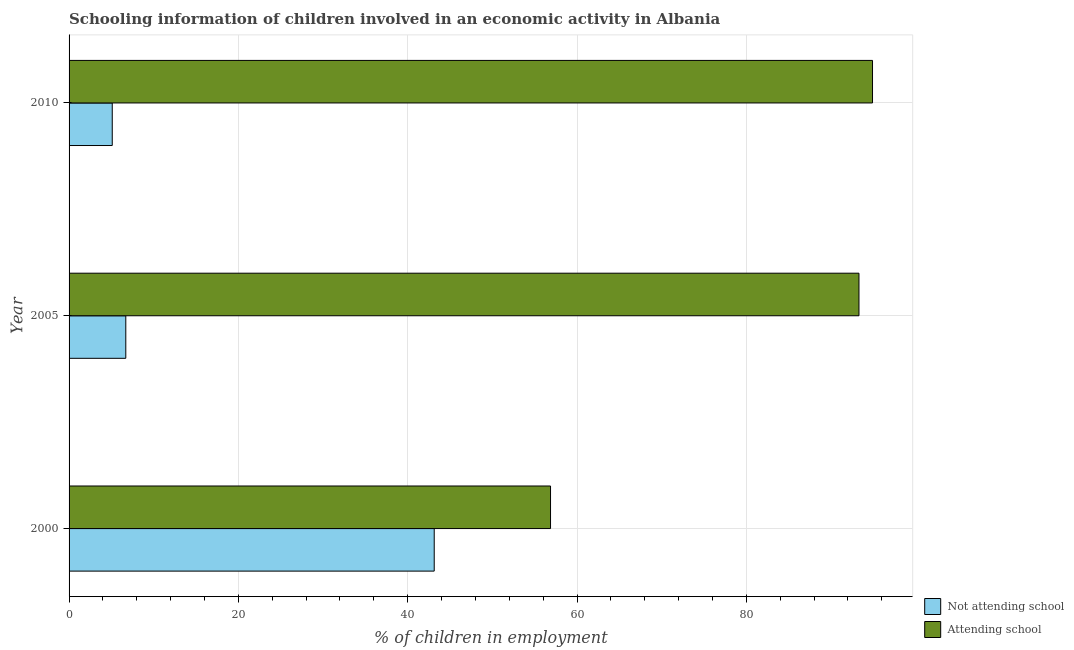How many groups of bars are there?
Your response must be concise. 3. Are the number of bars per tick equal to the number of legend labels?
Provide a short and direct response. Yes. Are the number of bars on each tick of the Y-axis equal?
Provide a succinct answer. Yes. How many bars are there on the 3rd tick from the bottom?
Your response must be concise. 2. Across all years, what is the maximum percentage of employed children who are not attending school?
Your response must be concise. 43.13. Across all years, what is the minimum percentage of employed children who are not attending school?
Keep it short and to the point. 5.1. In which year was the percentage of employed children who are attending school maximum?
Ensure brevity in your answer.  2010. In which year was the percentage of employed children who are attending school minimum?
Ensure brevity in your answer.  2000. What is the total percentage of employed children who are attending school in the graph?
Give a very brief answer. 245.07. What is the difference between the percentage of employed children who are attending school in 2000 and the percentage of employed children who are not attending school in 2005?
Keep it short and to the point. 50.17. What is the average percentage of employed children who are attending school per year?
Ensure brevity in your answer.  81.69. In the year 2000, what is the difference between the percentage of employed children who are attending school and percentage of employed children who are not attending school?
Provide a short and direct response. 13.74. In how many years, is the percentage of employed children who are not attending school greater than 56 %?
Keep it short and to the point. 0. Is the percentage of employed children who are attending school in 2000 less than that in 2010?
Ensure brevity in your answer.  Yes. Is the difference between the percentage of employed children who are not attending school in 2000 and 2010 greater than the difference between the percentage of employed children who are attending school in 2000 and 2010?
Make the answer very short. Yes. What is the difference between the highest and the lowest percentage of employed children who are not attending school?
Make the answer very short. 38.03. In how many years, is the percentage of employed children who are not attending school greater than the average percentage of employed children who are not attending school taken over all years?
Make the answer very short. 1. Is the sum of the percentage of employed children who are not attending school in 2000 and 2010 greater than the maximum percentage of employed children who are attending school across all years?
Offer a terse response. No. What does the 1st bar from the top in 2010 represents?
Keep it short and to the point. Attending school. What does the 1st bar from the bottom in 2000 represents?
Make the answer very short. Not attending school. How many bars are there?
Ensure brevity in your answer.  6. How many years are there in the graph?
Make the answer very short. 3. Does the graph contain any zero values?
Your answer should be very brief. No. Where does the legend appear in the graph?
Offer a terse response. Bottom right. How many legend labels are there?
Ensure brevity in your answer.  2. How are the legend labels stacked?
Give a very brief answer. Vertical. What is the title of the graph?
Provide a succinct answer. Schooling information of children involved in an economic activity in Albania. Does "Lowest 10% of population" appear as one of the legend labels in the graph?
Your answer should be compact. No. What is the label or title of the X-axis?
Ensure brevity in your answer.  % of children in employment. What is the % of children in employment in Not attending school in 2000?
Your response must be concise. 43.13. What is the % of children in employment of Attending school in 2000?
Provide a short and direct response. 56.87. What is the % of children in employment of Not attending school in 2005?
Offer a terse response. 6.7. What is the % of children in employment in Attending school in 2005?
Give a very brief answer. 93.3. What is the % of children in employment of Not attending school in 2010?
Your answer should be compact. 5.1. What is the % of children in employment of Attending school in 2010?
Your answer should be compact. 94.9. Across all years, what is the maximum % of children in employment in Not attending school?
Provide a succinct answer. 43.13. Across all years, what is the maximum % of children in employment of Attending school?
Your answer should be very brief. 94.9. Across all years, what is the minimum % of children in employment of Attending school?
Ensure brevity in your answer.  56.87. What is the total % of children in employment of Not attending school in the graph?
Make the answer very short. 54.93. What is the total % of children in employment in Attending school in the graph?
Your response must be concise. 245.07. What is the difference between the % of children in employment of Not attending school in 2000 and that in 2005?
Your answer should be very brief. 36.43. What is the difference between the % of children in employment of Attending school in 2000 and that in 2005?
Offer a very short reply. -36.43. What is the difference between the % of children in employment of Not attending school in 2000 and that in 2010?
Make the answer very short. 38.03. What is the difference between the % of children in employment of Attending school in 2000 and that in 2010?
Your response must be concise. -38.03. What is the difference between the % of children in employment of Attending school in 2005 and that in 2010?
Your answer should be very brief. -1.6. What is the difference between the % of children in employment in Not attending school in 2000 and the % of children in employment in Attending school in 2005?
Your answer should be very brief. -50.17. What is the difference between the % of children in employment of Not attending school in 2000 and the % of children in employment of Attending school in 2010?
Provide a succinct answer. -51.77. What is the difference between the % of children in employment in Not attending school in 2005 and the % of children in employment in Attending school in 2010?
Your response must be concise. -88.2. What is the average % of children in employment of Not attending school per year?
Offer a very short reply. 18.31. What is the average % of children in employment in Attending school per year?
Provide a short and direct response. 81.69. In the year 2000, what is the difference between the % of children in employment of Not attending school and % of children in employment of Attending school?
Offer a very short reply. -13.74. In the year 2005, what is the difference between the % of children in employment in Not attending school and % of children in employment in Attending school?
Keep it short and to the point. -86.6. In the year 2010, what is the difference between the % of children in employment in Not attending school and % of children in employment in Attending school?
Give a very brief answer. -89.8. What is the ratio of the % of children in employment of Not attending school in 2000 to that in 2005?
Provide a succinct answer. 6.44. What is the ratio of the % of children in employment of Attending school in 2000 to that in 2005?
Ensure brevity in your answer.  0.61. What is the ratio of the % of children in employment of Not attending school in 2000 to that in 2010?
Keep it short and to the point. 8.46. What is the ratio of the % of children in employment of Attending school in 2000 to that in 2010?
Your answer should be very brief. 0.6. What is the ratio of the % of children in employment of Not attending school in 2005 to that in 2010?
Make the answer very short. 1.31. What is the ratio of the % of children in employment of Attending school in 2005 to that in 2010?
Give a very brief answer. 0.98. What is the difference between the highest and the second highest % of children in employment of Not attending school?
Keep it short and to the point. 36.43. What is the difference between the highest and the lowest % of children in employment in Not attending school?
Offer a very short reply. 38.03. What is the difference between the highest and the lowest % of children in employment in Attending school?
Provide a succinct answer. 38.03. 